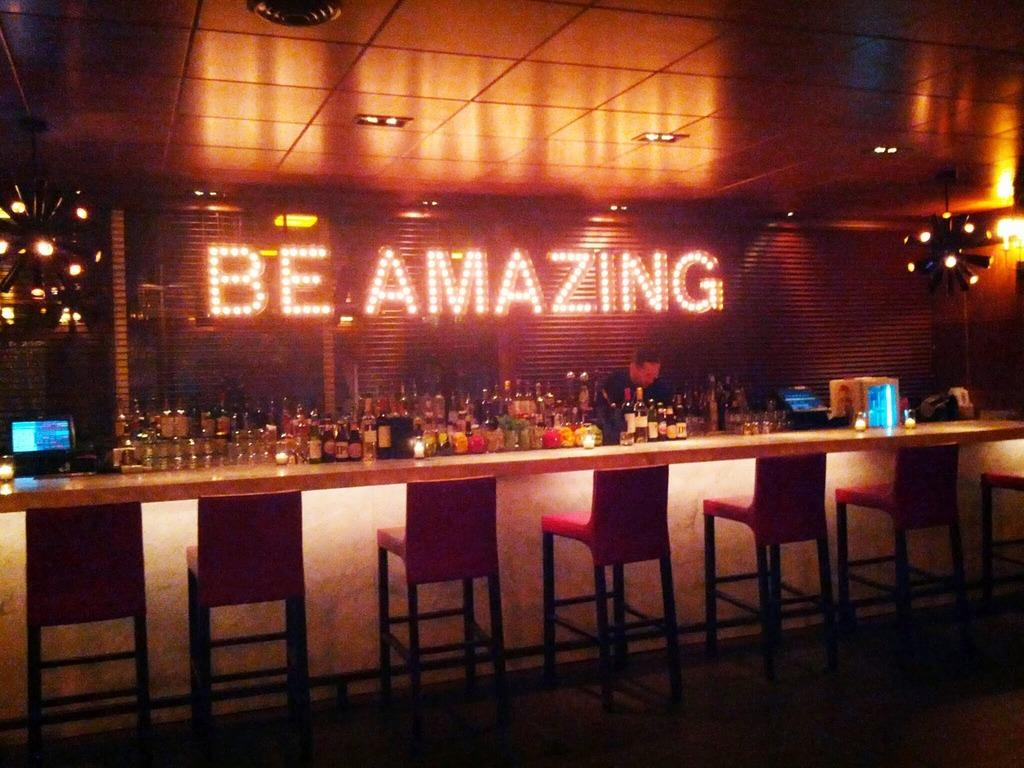What type of furniture is present in the image? There are chairs in the image. What beverage is associated with the items in the image? There are wine bottles in the image. How does the image convey a particular mood or atmosphere? The image features lights that create an amazing atmosphere. What hobbies does the person in the image enjoy? There is no person present in the image, so it is impossible to determine their hobbies. 